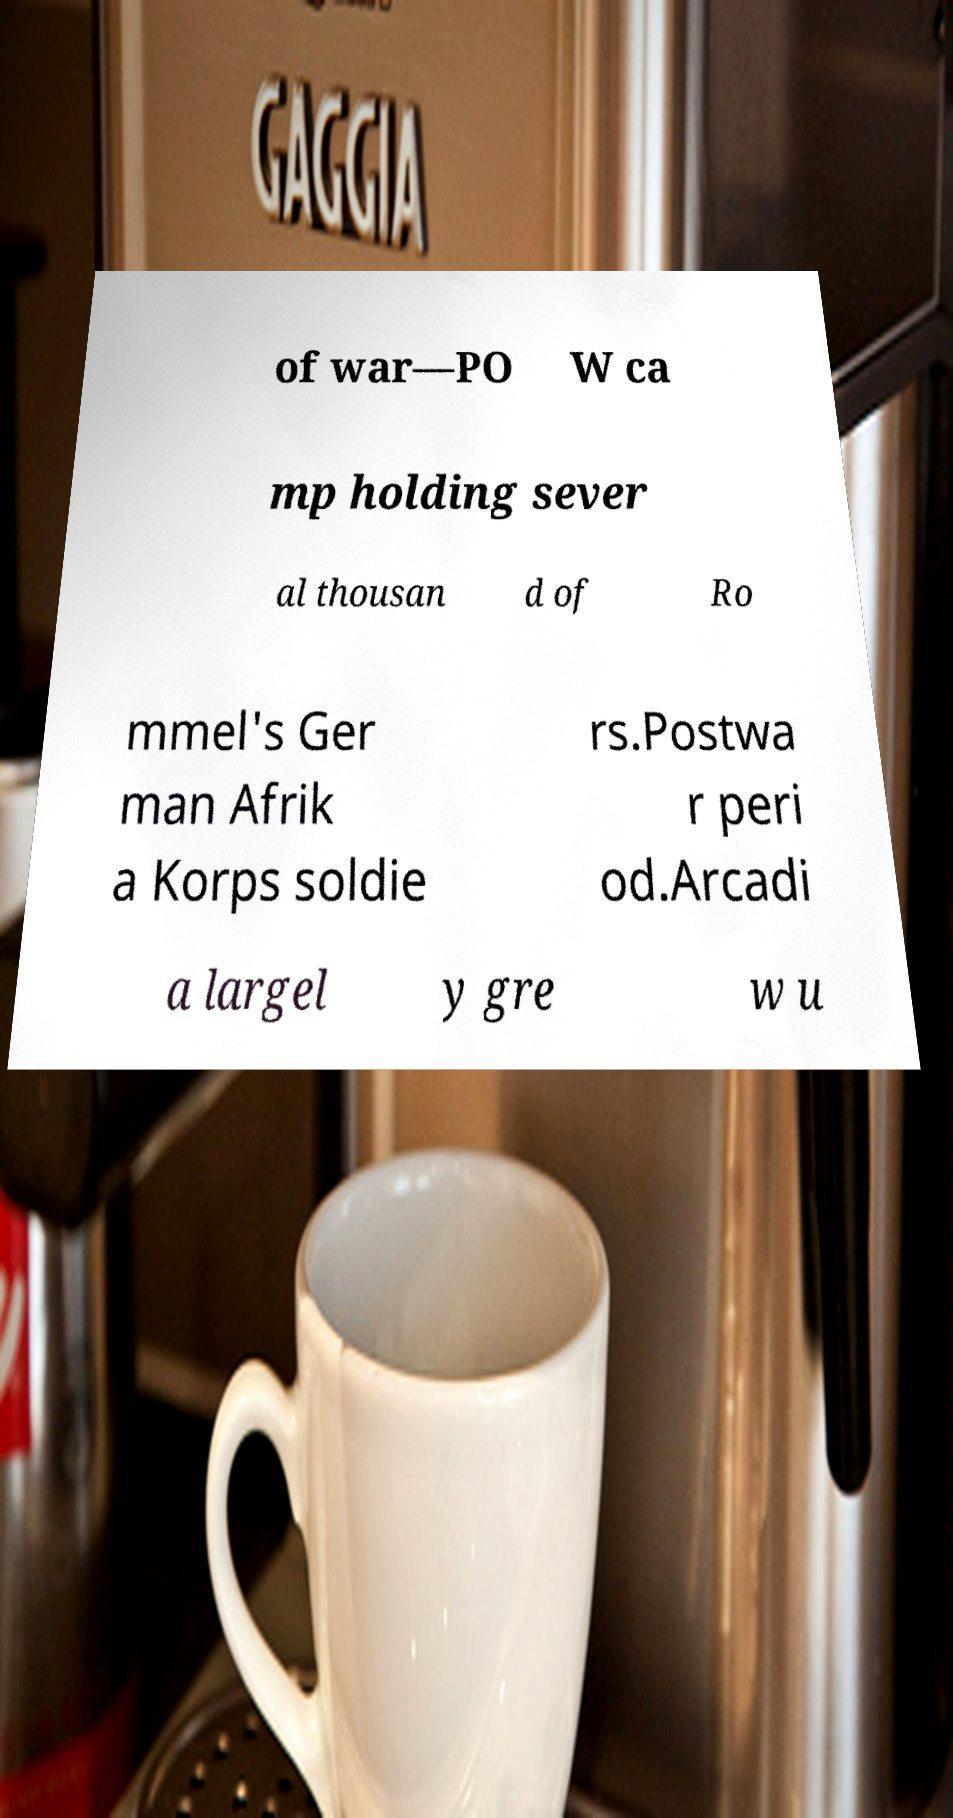I need the written content from this picture converted into text. Can you do that? of war—PO W ca mp holding sever al thousan d of Ro mmel's Ger man Afrik a Korps soldie rs.Postwa r peri od.Arcadi a largel y gre w u 